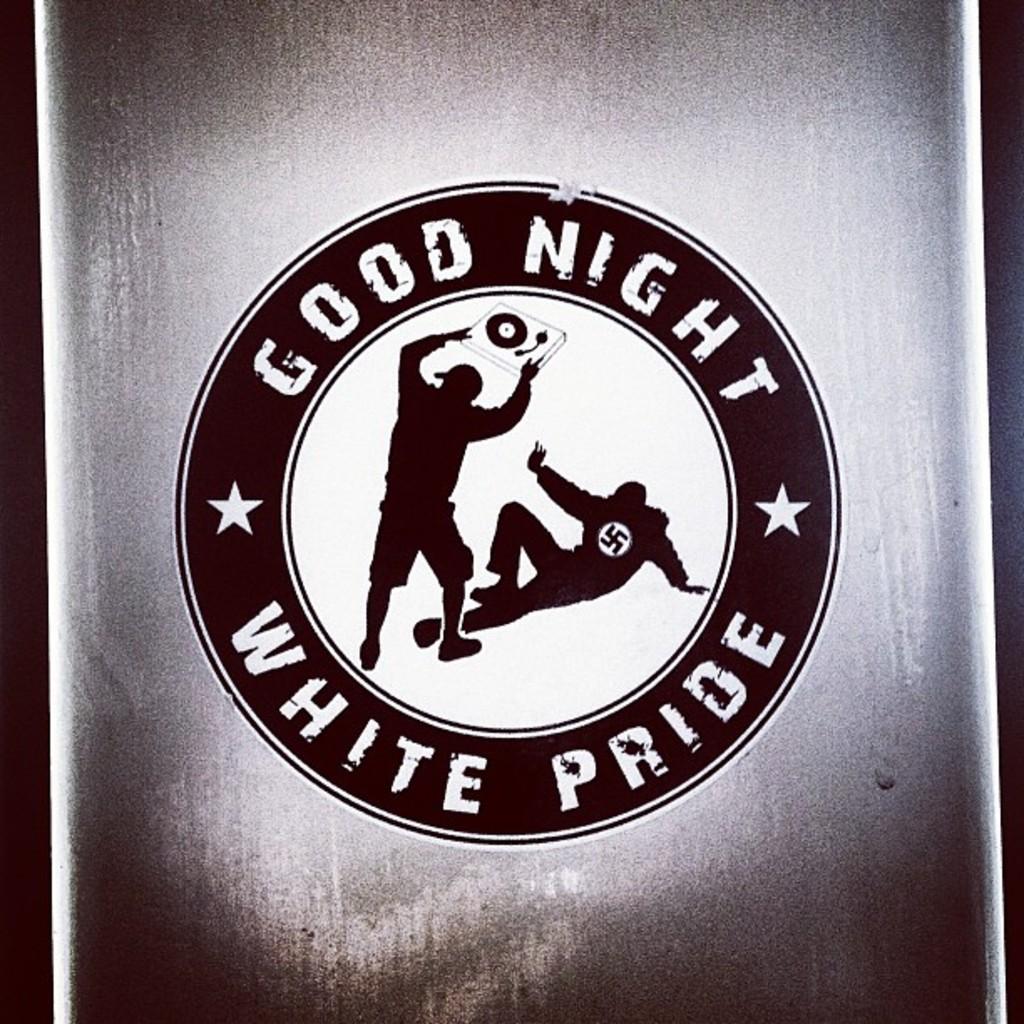What kind of night is it?
Make the answer very short. Good. 